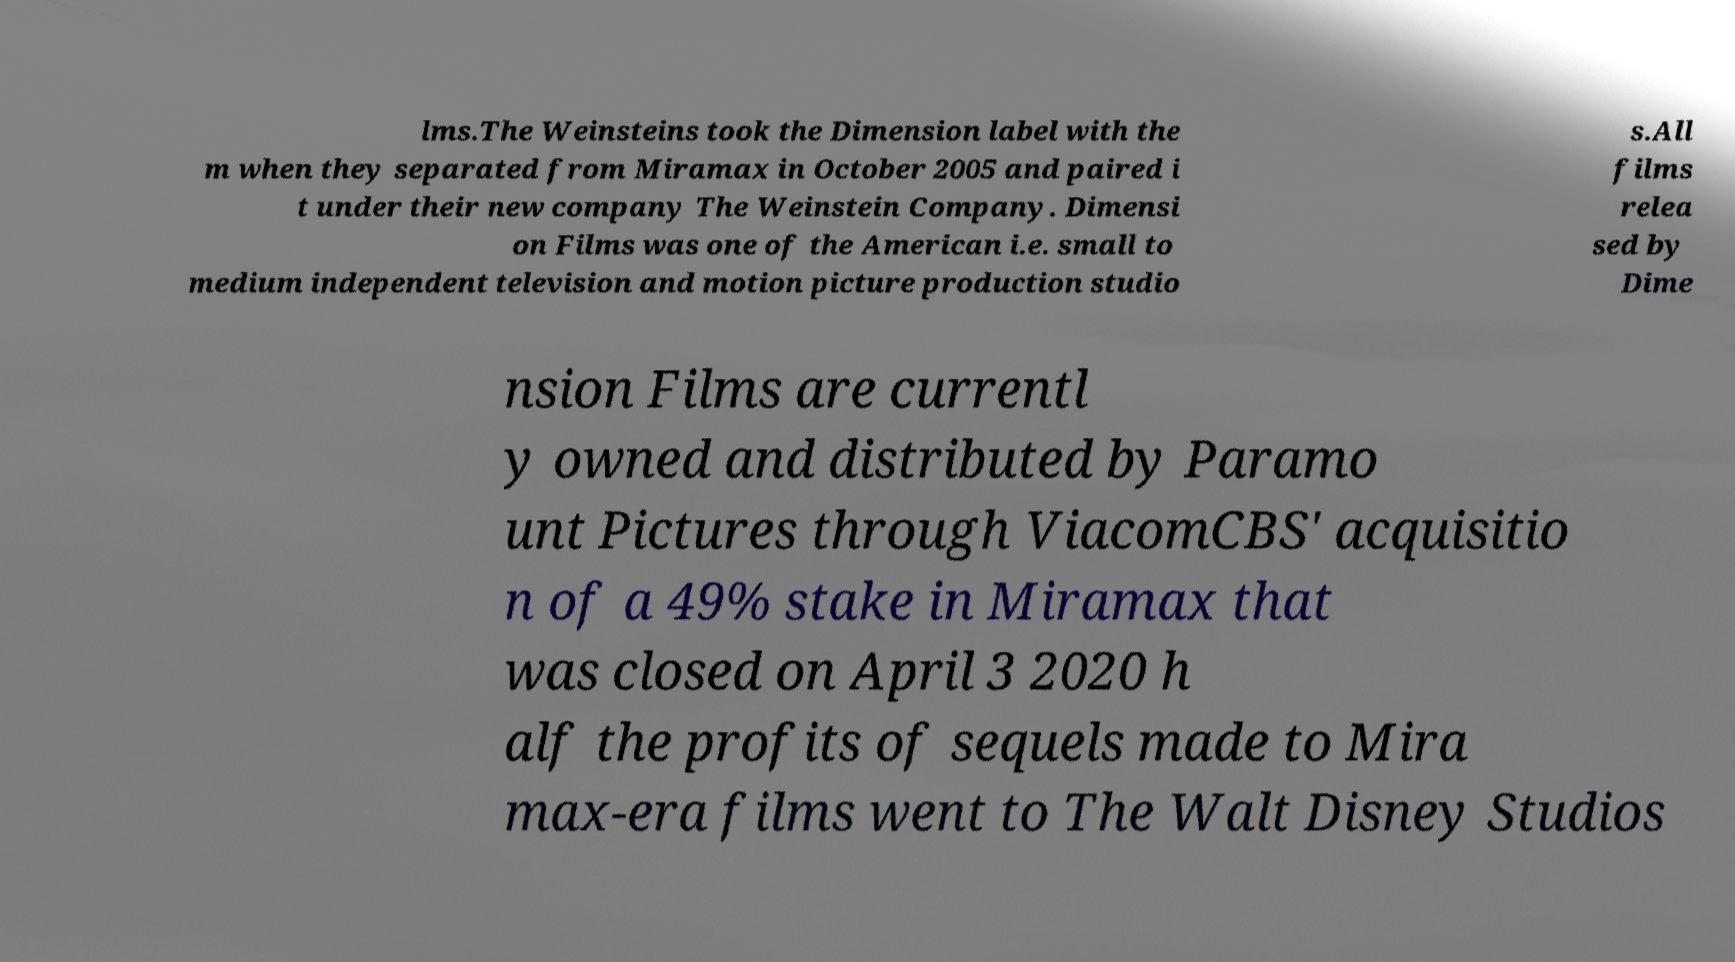There's text embedded in this image that I need extracted. Can you transcribe it verbatim? lms.The Weinsteins took the Dimension label with the m when they separated from Miramax in October 2005 and paired i t under their new company The Weinstein Company. Dimensi on Films was one of the American i.e. small to medium independent television and motion picture production studio s.All films relea sed by Dime nsion Films are currentl y owned and distributed by Paramo unt Pictures through ViacomCBS' acquisitio n of a 49% stake in Miramax that was closed on April 3 2020 h alf the profits of sequels made to Mira max-era films went to The Walt Disney Studios 